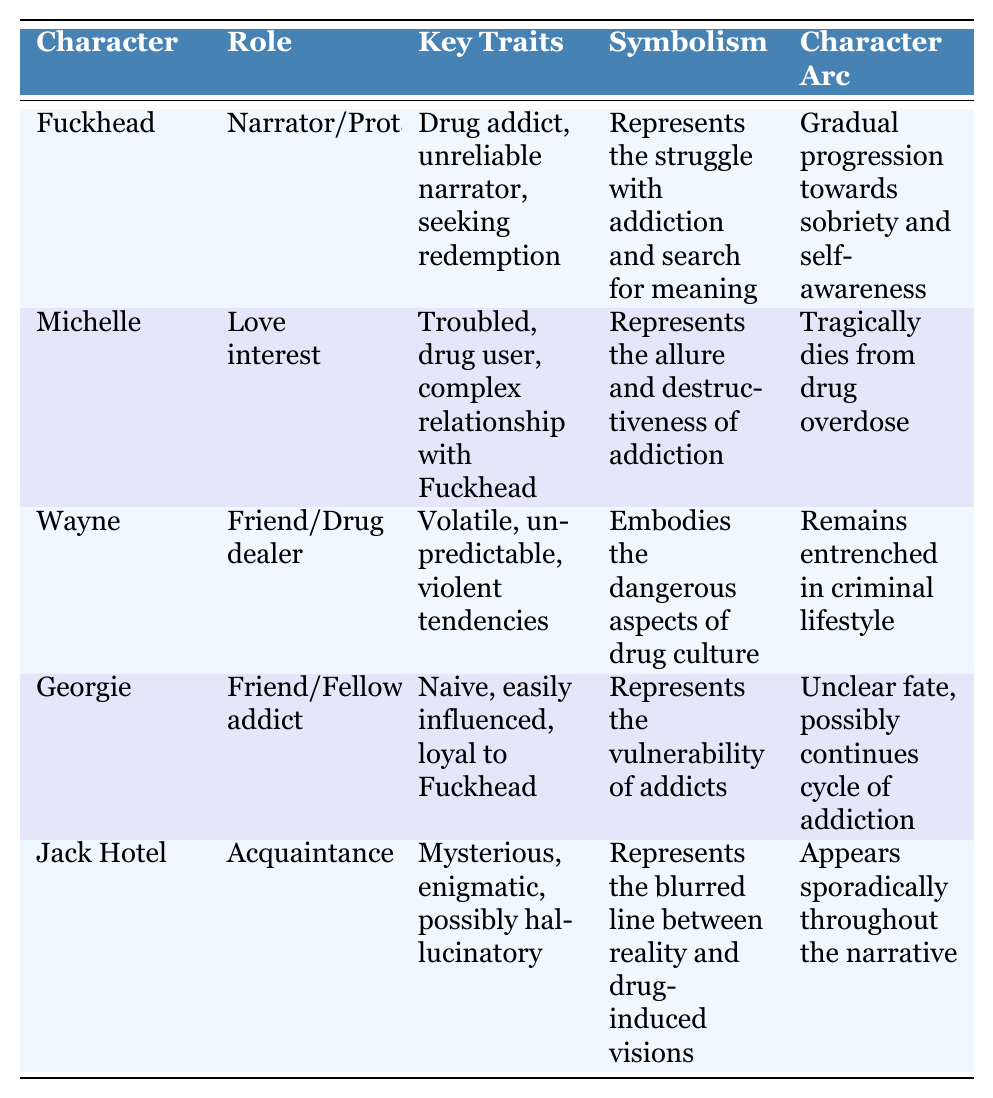What is Fuckhead's character arc? The table states that Fuckhead's character arc is a "Gradual progression towards sobriety and self-awareness."
Answer: Gradual progression towards sobriety and self-awareness Who is described as the love interest? The table specifies that Michelle has the role of "Love interest."
Answer: Michelle Which character symbolizes the allure and destructiveness of addiction? According to the table, Michelle represents the allure and destructiveness of addiction.
Answer: Michelle What are the key traits of Wayne? The table lists Wayne's key traits as "Volatile, unpredictable, violent tendencies."
Answer: Volatile, unpredictable, violent tendencies Do any characters have an unclear fate? The table indicates that Georgie's fate is "Unclear, possibly continues cycle of addiction," therefore the answer is yes.
Answer: Yes Which character appears sporadically throughout the narrative? The table notes that Jack Hotel appears sporadically, making him the correct answer.
Answer: Jack Hotel How many key traits are mentioned for Michelle? The table notes that Michelle has three key traits: "Troubled, drug user, complex relationship with Fuckhead," so the count is three.
Answer: Three Is Wayne’s character arc positive or negative? The table suggests that Wayne remains entrenched in a criminal lifestyle, indicating a negative arc.
Answer: Negative Which character has a notable scene involving a hospital visit? The table lists Fuckhead with notable scenes that include a "hospital visit," indicating he is the character in question.
Answer: Fuckhead Compare the character arcs of Fuckhead and Michelle. Fuckhead's arc shows a progression towards sobriety, while Michelle's arc ends with her tragic death from an overdose, contrasting their journeys.
Answer: Their arcs diverge; Fuckhead seeks sobriety while Michelle tragically dies What do both Fuckhead and Georgie symbolize? According to the table, Fuckhead represents the struggle with addiction, and Georgie represents the vulnerability of addicts, emphasizing different aspects of addiction.
Answer: Different aspects of addiction 